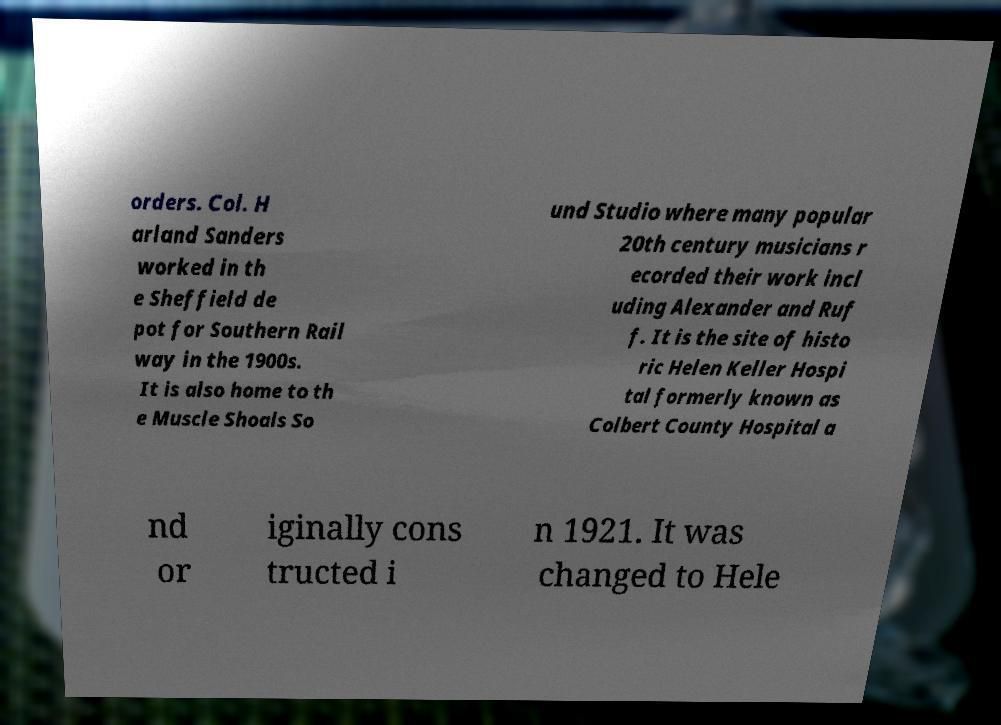For documentation purposes, I need the text within this image transcribed. Could you provide that? orders. Col. H arland Sanders worked in th e Sheffield de pot for Southern Rail way in the 1900s. It is also home to th e Muscle Shoals So und Studio where many popular 20th century musicians r ecorded their work incl uding Alexander and Ruf f. It is the site of histo ric Helen Keller Hospi tal formerly known as Colbert County Hospital a nd or iginally cons tructed i n 1921. It was changed to Hele 